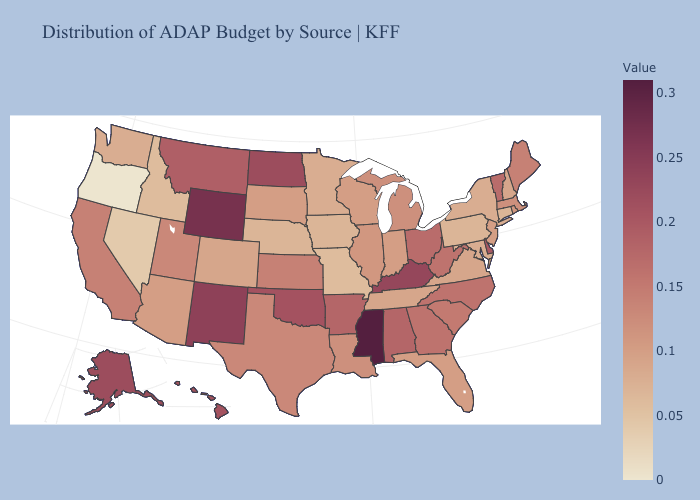Which states hav the highest value in the Northeast?
Keep it brief. Vermont. Among the states that border Georgia , does Tennessee have the lowest value?
Be succinct. Yes. Which states have the highest value in the USA?
Give a very brief answer. Mississippi. Which states have the highest value in the USA?
Answer briefly. Mississippi. Does Colorado have a higher value than Montana?
Be succinct. No. Does New York have a higher value than Hawaii?
Answer briefly. No. 